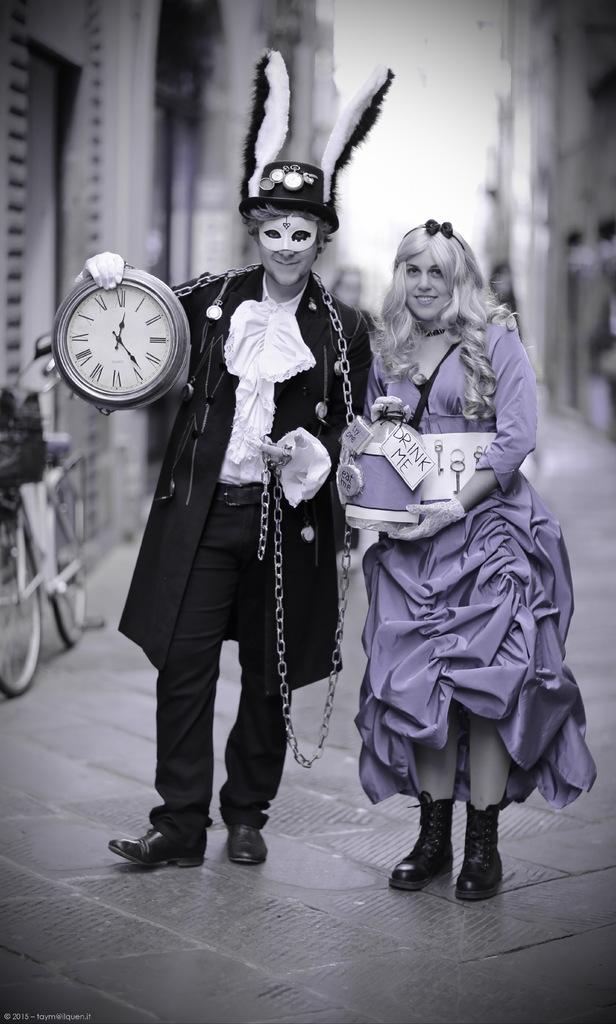Is it after 12:00 on that clock?
Give a very brief answer. Yes. What time is it?
Make the answer very short. 12:24. 